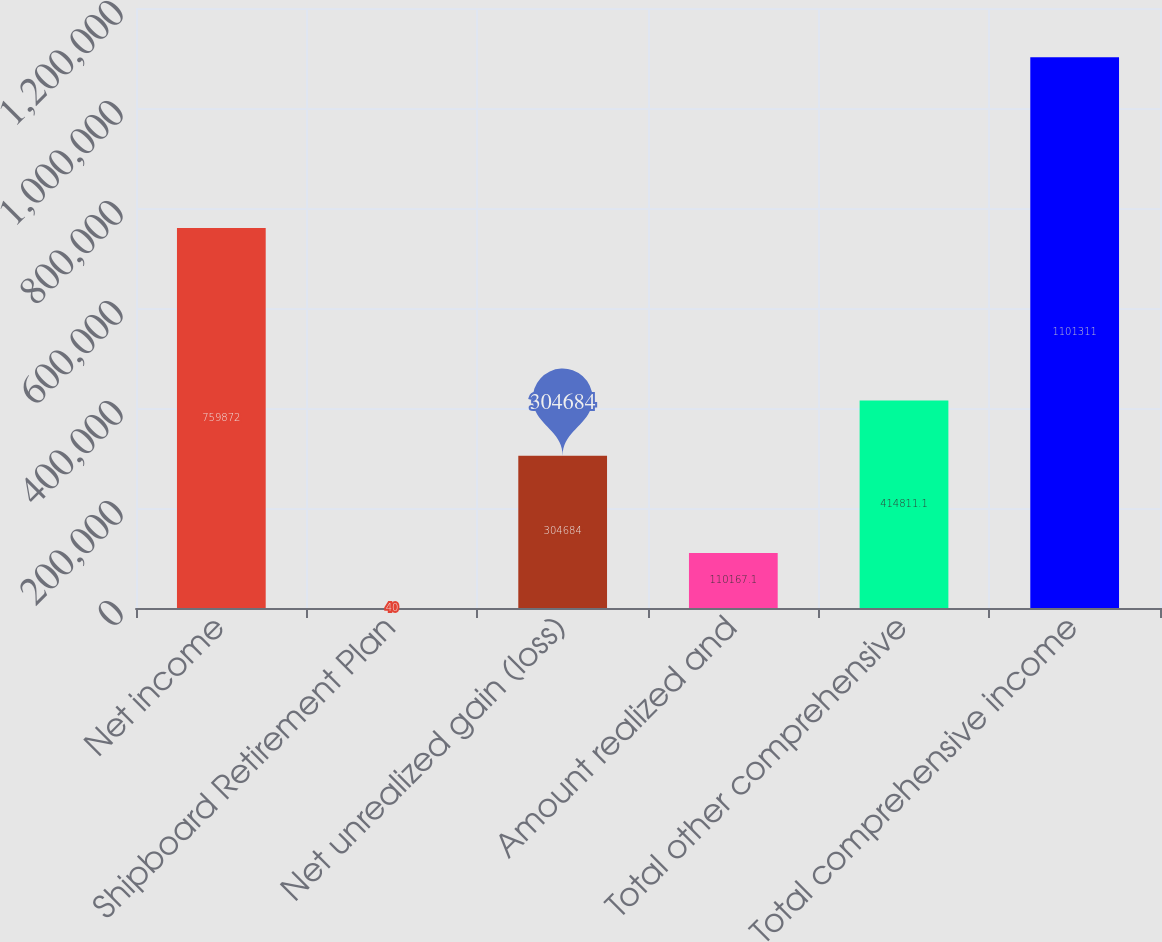<chart> <loc_0><loc_0><loc_500><loc_500><bar_chart><fcel>Net income<fcel>Shipboard Retirement Plan<fcel>Net unrealized gain (loss)<fcel>Amount realized and<fcel>Total other comprehensive<fcel>Total comprehensive income<nl><fcel>759872<fcel>40<fcel>304684<fcel>110167<fcel>414811<fcel>1.10131e+06<nl></chart> 